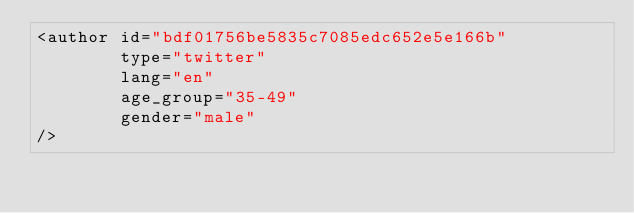<code> <loc_0><loc_0><loc_500><loc_500><_XML_><author id="bdf01756be5835c7085edc652e5e166b"
		type="twitter"
		lang="en"
		age_group="35-49"
		gender="male"
/>
</code> 